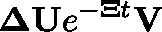Convert formula to latex. <formula><loc_0><loc_0><loc_500><loc_500>\Delta U e ^ { - \Xi t } V</formula> 